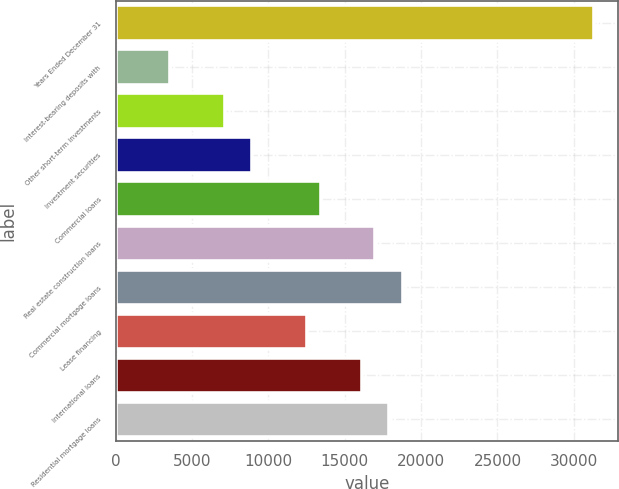Convert chart. <chart><loc_0><loc_0><loc_500><loc_500><bar_chart><fcel>Years Ended December 31<fcel>Interest-bearing deposits with<fcel>Other short-term investments<fcel>Investment securities<fcel>Commercial loans<fcel>Real estate construction loans<fcel>Commercial mortgage loans<fcel>Lease financing<fcel>International loans<fcel>Residential mortgage loans<nl><fcel>31317.7<fcel>3579.23<fcel>7158.39<fcel>8947.97<fcel>13421.9<fcel>17001.1<fcel>18790.7<fcel>12527.1<fcel>16106.3<fcel>17895.9<nl></chart> 